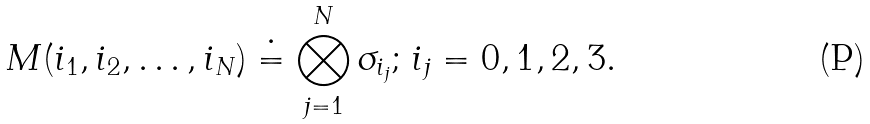Convert formula to latex. <formula><loc_0><loc_0><loc_500><loc_500>M ( i _ { 1 } , i _ { 2 } , \dots , i _ { N } ) \doteq \bigotimes _ { j = 1 } ^ { N } \sigma _ { i _ { j } } ; \, i _ { j } = 0 , 1 , 2 , 3 .</formula> 